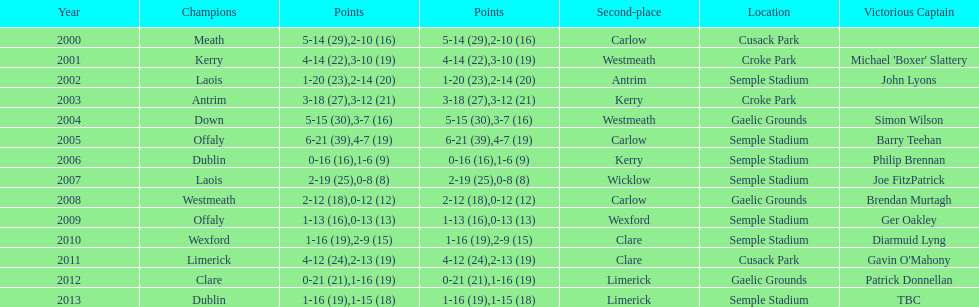Who was the winner after 2007? Laois. 